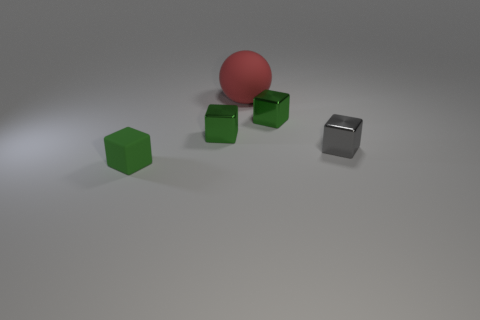What is the small gray block made of?
Your answer should be compact. Metal. There is a matte thing behind the small green matte thing; what color is it?
Keep it short and to the point. Red. How many tiny matte blocks are the same color as the rubber ball?
Make the answer very short. 0. How many tiny shiny cubes are both behind the tiny gray object and on the right side of the rubber sphere?
Your response must be concise. 1. What size is the red matte object?
Provide a short and direct response. Large. There is a object that is behind the tiny block behind the small green metallic object to the left of the large ball; what is its material?
Make the answer very short. Rubber. There is a cube that is made of the same material as the red sphere; what color is it?
Provide a short and direct response. Green. There is a large object behind the tiny green metallic block that is to the left of the large red ball; how many cubes are to the left of it?
Provide a short and direct response. 2. Are there any other things that have the same shape as the big red thing?
Give a very brief answer. No. How many things are small green things behind the rubber cube or small brown things?
Give a very brief answer. 2. 